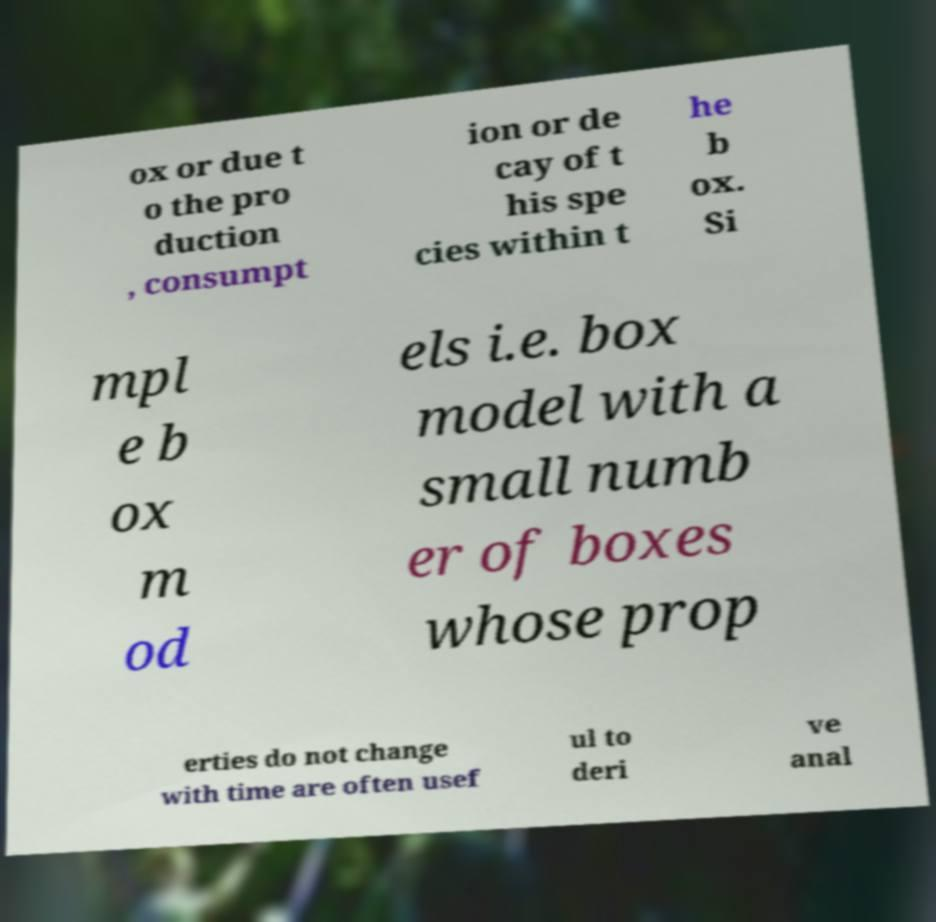Can you accurately transcribe the text from the provided image for me? ox or due t o the pro duction , consumpt ion or de cay of t his spe cies within t he b ox. Si mpl e b ox m od els i.e. box model with a small numb er of boxes whose prop erties do not change with time are often usef ul to deri ve anal 